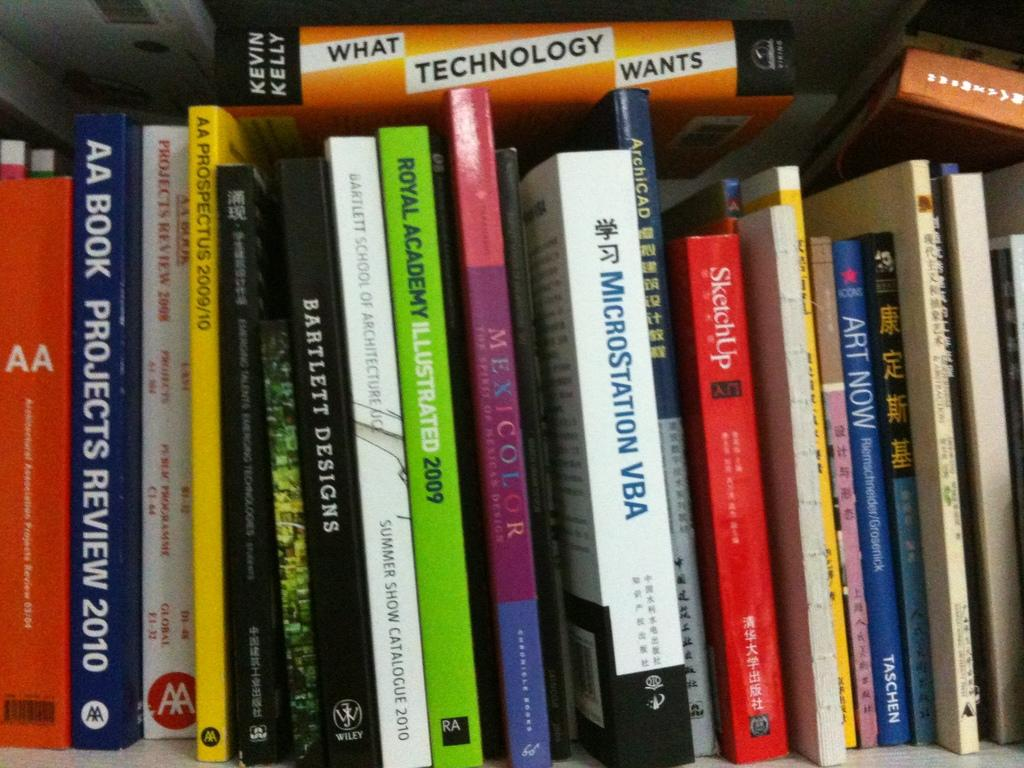What types of objects are present in the image? There are different kinds of books in the image. Can you describe the books in the image? The image shows various books, but no specific details about their titles or subjects are provided. Where is the toad sitting in the image? There is no toad present in the image; it only features different kinds of books. 